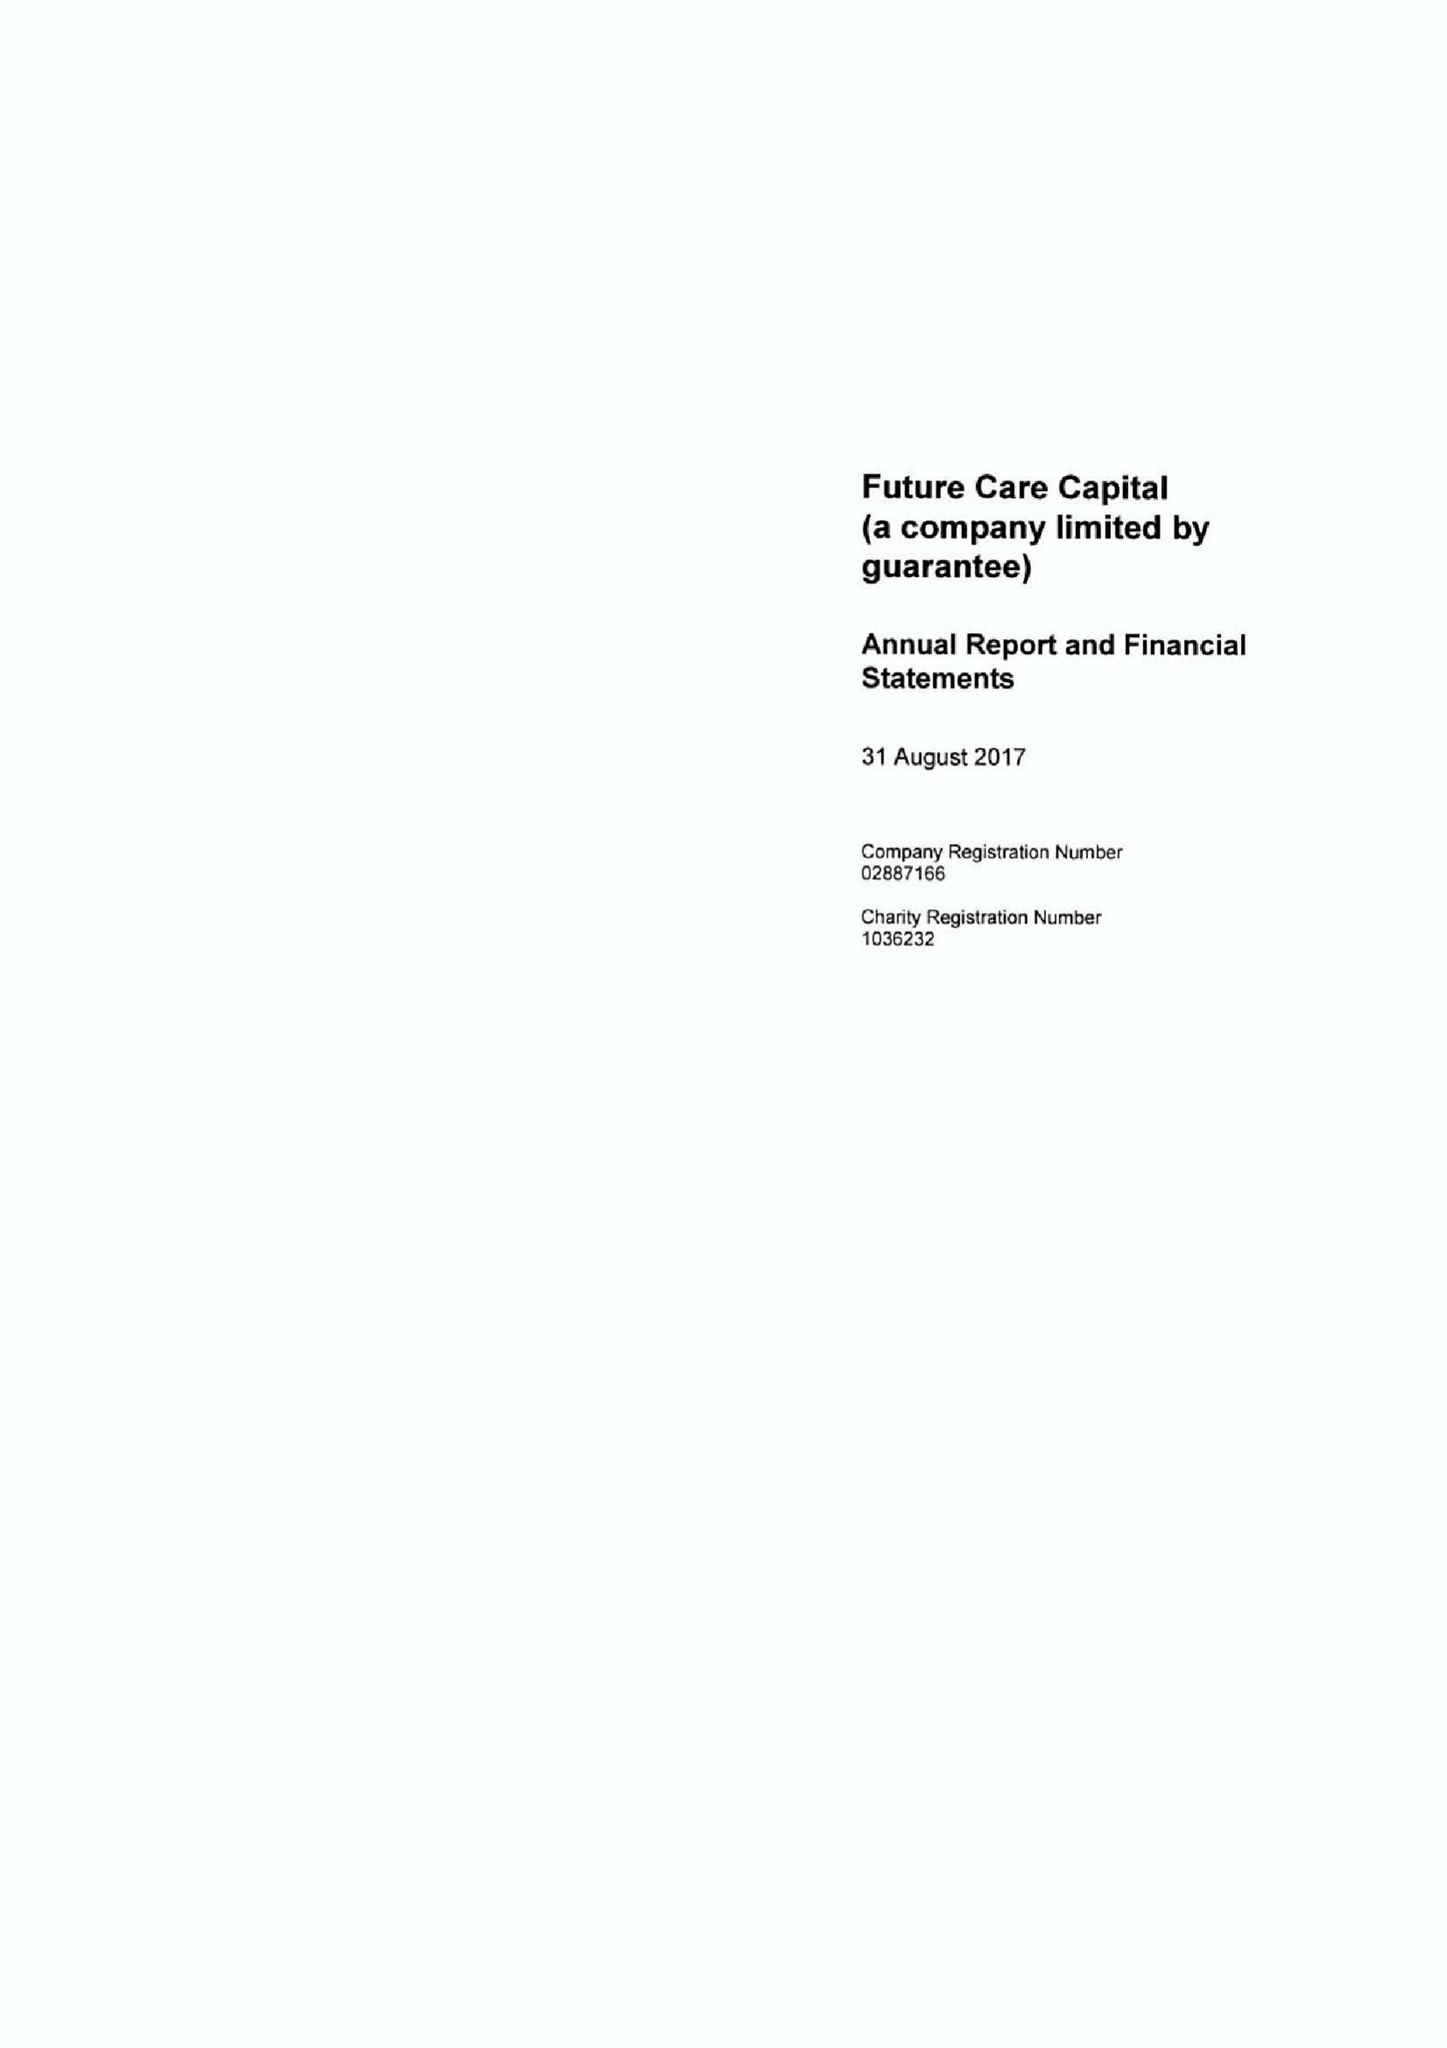What is the value for the report_date?
Answer the question using a single word or phrase. 2017-08-31 